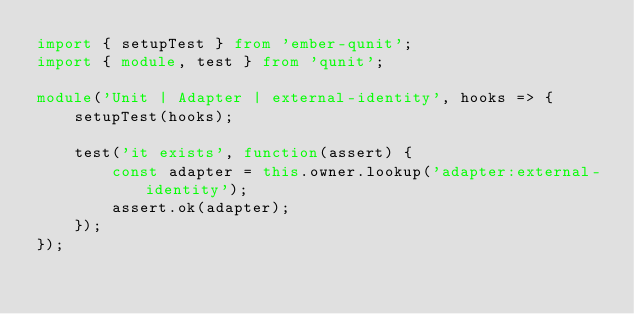Convert code to text. <code><loc_0><loc_0><loc_500><loc_500><_TypeScript_>import { setupTest } from 'ember-qunit';
import { module, test } from 'qunit';

module('Unit | Adapter | external-identity', hooks => {
    setupTest(hooks);

    test('it exists', function(assert) {
        const adapter = this.owner.lookup('adapter:external-identity');
        assert.ok(adapter);
    });
});
</code> 